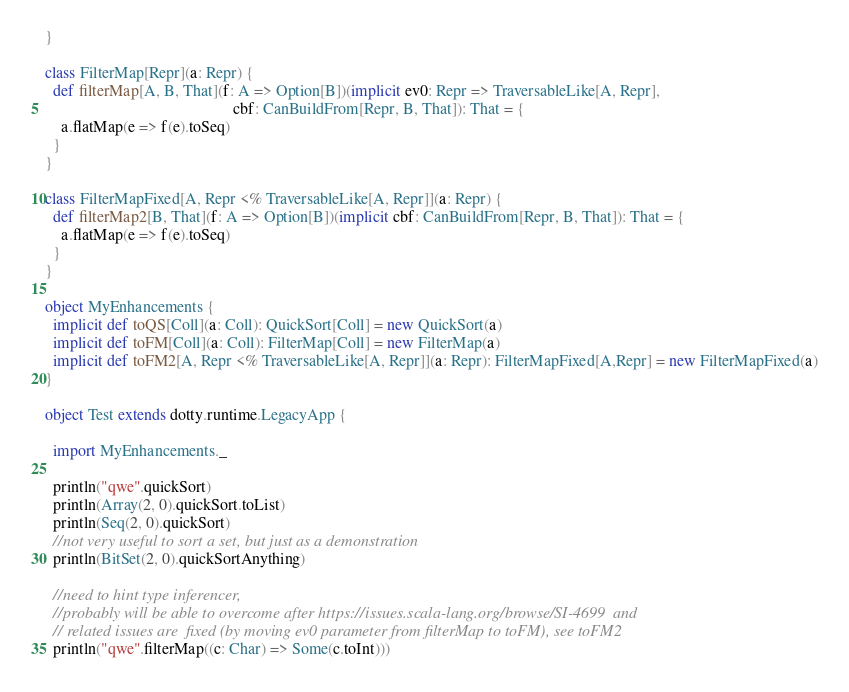Convert code to text. <code><loc_0><loc_0><loc_500><loc_500><_Scala_>}

class FilterMap[Repr](a: Repr) {
  def filterMap[A, B, That](f: A => Option[B])(implicit ev0: Repr => TraversableLike[A, Repr],
                                               cbf: CanBuildFrom[Repr, B, That]): That = {
    a.flatMap(e => f(e).toSeq)
  }
}

class FilterMapFixed[A, Repr <% TraversableLike[A, Repr]](a: Repr) {
  def filterMap2[B, That](f: A => Option[B])(implicit cbf: CanBuildFrom[Repr, B, That]): That = {
    a.flatMap(e => f(e).toSeq)
  }
}

object MyEnhancements {
  implicit def toQS[Coll](a: Coll): QuickSort[Coll] = new QuickSort(a)
  implicit def toFM[Coll](a: Coll): FilterMap[Coll] = new FilterMap(a)
  implicit def toFM2[A, Repr <% TraversableLike[A, Repr]](a: Repr): FilterMapFixed[A,Repr] = new FilterMapFixed(a)
}

object Test extends dotty.runtime.LegacyApp {

  import MyEnhancements._

  println("qwe".quickSort)
  println(Array(2, 0).quickSort.toList)
  println(Seq(2, 0).quickSort)
  //not very useful to sort a set, but just as a demonstration
  println(BitSet(2, 0).quickSortAnything)

  //need to hint type inferencer,
  //probably will be able to overcome after https://issues.scala-lang.org/browse/SI-4699  and
  // related issues are  fixed (by moving ev0 parameter from filterMap to toFM), see toFM2
  println("qwe".filterMap((c: Char) => Some(c.toInt)))</code> 